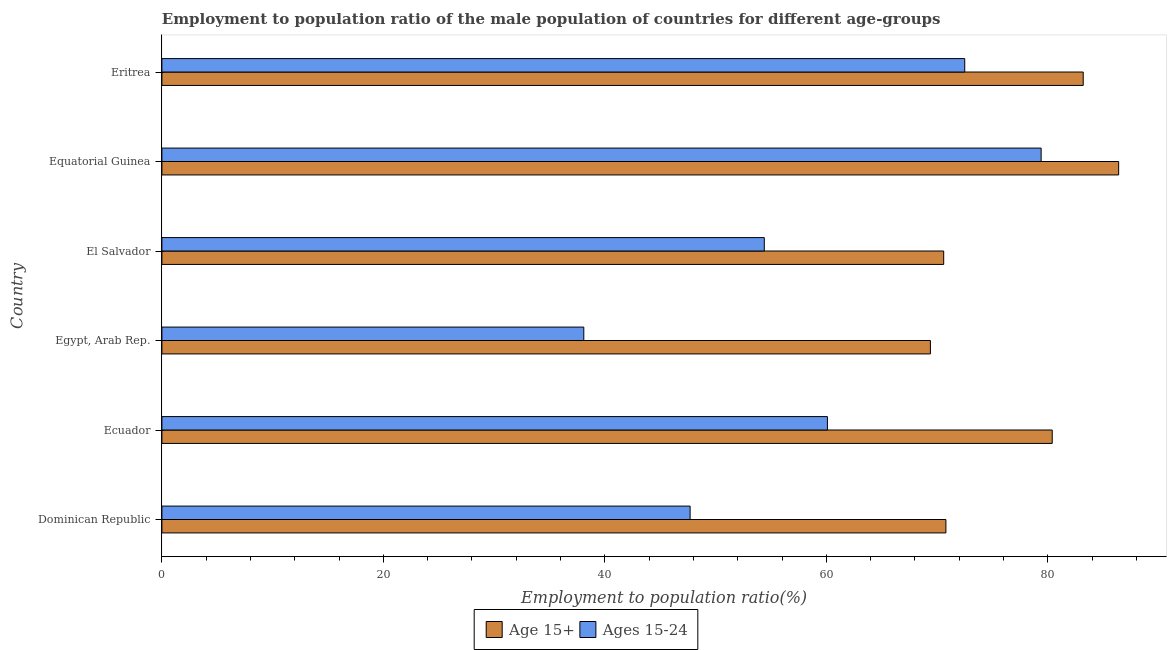What is the label of the 2nd group of bars from the top?
Your response must be concise. Equatorial Guinea. In how many cases, is the number of bars for a given country not equal to the number of legend labels?
Offer a very short reply. 0. What is the employment to population ratio(age 15-24) in Equatorial Guinea?
Keep it short and to the point. 79.4. Across all countries, what is the maximum employment to population ratio(age 15-24)?
Offer a very short reply. 79.4. Across all countries, what is the minimum employment to population ratio(age 15+)?
Your answer should be very brief. 69.4. In which country was the employment to population ratio(age 15-24) maximum?
Your answer should be very brief. Equatorial Guinea. In which country was the employment to population ratio(age 15+) minimum?
Offer a very short reply. Egypt, Arab Rep. What is the total employment to population ratio(age 15-24) in the graph?
Keep it short and to the point. 352.2. What is the difference between the employment to population ratio(age 15-24) in Egypt, Arab Rep. and that in Eritrea?
Provide a short and direct response. -34.4. What is the difference between the employment to population ratio(age 15+) in Ecuador and the employment to population ratio(age 15-24) in Eritrea?
Your response must be concise. 7.9. What is the average employment to population ratio(age 15-24) per country?
Your answer should be compact. 58.7. What is the difference between the employment to population ratio(age 15+) and employment to population ratio(age 15-24) in Eritrea?
Ensure brevity in your answer.  10.7. What is the ratio of the employment to population ratio(age 15-24) in Dominican Republic to that in Egypt, Arab Rep.?
Your answer should be compact. 1.25. Is the employment to population ratio(age 15+) in Egypt, Arab Rep. less than that in Eritrea?
Your answer should be compact. Yes. What is the difference between the highest and the second highest employment to population ratio(age 15-24)?
Your response must be concise. 6.9. What is the difference between the highest and the lowest employment to population ratio(age 15-24)?
Keep it short and to the point. 41.3. In how many countries, is the employment to population ratio(age 15+) greater than the average employment to population ratio(age 15+) taken over all countries?
Your answer should be very brief. 3. What does the 1st bar from the top in Dominican Republic represents?
Provide a short and direct response. Ages 15-24. What does the 2nd bar from the bottom in El Salvador represents?
Make the answer very short. Ages 15-24. How many bars are there?
Offer a very short reply. 12. Are all the bars in the graph horizontal?
Make the answer very short. Yes. Does the graph contain grids?
Provide a short and direct response. No. Where does the legend appear in the graph?
Provide a short and direct response. Bottom center. How many legend labels are there?
Your answer should be compact. 2. How are the legend labels stacked?
Offer a very short reply. Horizontal. What is the title of the graph?
Your answer should be compact. Employment to population ratio of the male population of countries for different age-groups. What is the Employment to population ratio(%) of Age 15+ in Dominican Republic?
Provide a short and direct response. 70.8. What is the Employment to population ratio(%) of Ages 15-24 in Dominican Republic?
Ensure brevity in your answer.  47.7. What is the Employment to population ratio(%) in Age 15+ in Ecuador?
Give a very brief answer. 80.4. What is the Employment to population ratio(%) of Ages 15-24 in Ecuador?
Keep it short and to the point. 60.1. What is the Employment to population ratio(%) of Age 15+ in Egypt, Arab Rep.?
Provide a short and direct response. 69.4. What is the Employment to population ratio(%) in Ages 15-24 in Egypt, Arab Rep.?
Offer a terse response. 38.1. What is the Employment to population ratio(%) in Age 15+ in El Salvador?
Provide a short and direct response. 70.6. What is the Employment to population ratio(%) of Ages 15-24 in El Salvador?
Keep it short and to the point. 54.4. What is the Employment to population ratio(%) in Age 15+ in Equatorial Guinea?
Your answer should be very brief. 86.4. What is the Employment to population ratio(%) in Ages 15-24 in Equatorial Guinea?
Offer a very short reply. 79.4. What is the Employment to population ratio(%) in Age 15+ in Eritrea?
Provide a succinct answer. 83.2. What is the Employment to population ratio(%) in Ages 15-24 in Eritrea?
Ensure brevity in your answer.  72.5. Across all countries, what is the maximum Employment to population ratio(%) of Age 15+?
Make the answer very short. 86.4. Across all countries, what is the maximum Employment to population ratio(%) in Ages 15-24?
Offer a terse response. 79.4. Across all countries, what is the minimum Employment to population ratio(%) of Age 15+?
Offer a very short reply. 69.4. Across all countries, what is the minimum Employment to population ratio(%) of Ages 15-24?
Your answer should be compact. 38.1. What is the total Employment to population ratio(%) in Age 15+ in the graph?
Your answer should be very brief. 460.8. What is the total Employment to population ratio(%) in Ages 15-24 in the graph?
Keep it short and to the point. 352.2. What is the difference between the Employment to population ratio(%) of Age 15+ in Dominican Republic and that in Ecuador?
Provide a short and direct response. -9.6. What is the difference between the Employment to population ratio(%) of Ages 15-24 in Dominican Republic and that in Ecuador?
Keep it short and to the point. -12.4. What is the difference between the Employment to population ratio(%) in Ages 15-24 in Dominican Republic and that in El Salvador?
Ensure brevity in your answer.  -6.7. What is the difference between the Employment to population ratio(%) of Age 15+ in Dominican Republic and that in Equatorial Guinea?
Offer a terse response. -15.6. What is the difference between the Employment to population ratio(%) of Ages 15-24 in Dominican Republic and that in Equatorial Guinea?
Provide a short and direct response. -31.7. What is the difference between the Employment to population ratio(%) of Ages 15-24 in Dominican Republic and that in Eritrea?
Offer a terse response. -24.8. What is the difference between the Employment to population ratio(%) in Age 15+ in Ecuador and that in Egypt, Arab Rep.?
Provide a succinct answer. 11. What is the difference between the Employment to population ratio(%) of Age 15+ in Ecuador and that in El Salvador?
Your answer should be compact. 9.8. What is the difference between the Employment to population ratio(%) in Ages 15-24 in Ecuador and that in Equatorial Guinea?
Give a very brief answer. -19.3. What is the difference between the Employment to population ratio(%) in Ages 15-24 in Egypt, Arab Rep. and that in El Salvador?
Provide a succinct answer. -16.3. What is the difference between the Employment to population ratio(%) in Ages 15-24 in Egypt, Arab Rep. and that in Equatorial Guinea?
Offer a very short reply. -41.3. What is the difference between the Employment to population ratio(%) of Age 15+ in Egypt, Arab Rep. and that in Eritrea?
Provide a succinct answer. -13.8. What is the difference between the Employment to population ratio(%) of Ages 15-24 in Egypt, Arab Rep. and that in Eritrea?
Offer a very short reply. -34.4. What is the difference between the Employment to population ratio(%) in Age 15+ in El Salvador and that in Equatorial Guinea?
Your answer should be compact. -15.8. What is the difference between the Employment to population ratio(%) in Age 15+ in El Salvador and that in Eritrea?
Provide a short and direct response. -12.6. What is the difference between the Employment to population ratio(%) in Ages 15-24 in El Salvador and that in Eritrea?
Provide a succinct answer. -18.1. What is the difference between the Employment to population ratio(%) in Ages 15-24 in Equatorial Guinea and that in Eritrea?
Your answer should be very brief. 6.9. What is the difference between the Employment to population ratio(%) of Age 15+ in Dominican Republic and the Employment to population ratio(%) of Ages 15-24 in Ecuador?
Make the answer very short. 10.7. What is the difference between the Employment to population ratio(%) in Age 15+ in Dominican Republic and the Employment to population ratio(%) in Ages 15-24 in Egypt, Arab Rep.?
Make the answer very short. 32.7. What is the difference between the Employment to population ratio(%) of Age 15+ in Dominican Republic and the Employment to population ratio(%) of Ages 15-24 in El Salvador?
Offer a very short reply. 16.4. What is the difference between the Employment to population ratio(%) of Age 15+ in Ecuador and the Employment to population ratio(%) of Ages 15-24 in Egypt, Arab Rep.?
Your answer should be compact. 42.3. What is the difference between the Employment to population ratio(%) in Age 15+ in Egypt, Arab Rep. and the Employment to population ratio(%) in Ages 15-24 in Eritrea?
Offer a very short reply. -3.1. What is the difference between the Employment to population ratio(%) in Age 15+ in Equatorial Guinea and the Employment to population ratio(%) in Ages 15-24 in Eritrea?
Keep it short and to the point. 13.9. What is the average Employment to population ratio(%) in Age 15+ per country?
Offer a terse response. 76.8. What is the average Employment to population ratio(%) of Ages 15-24 per country?
Keep it short and to the point. 58.7. What is the difference between the Employment to population ratio(%) in Age 15+ and Employment to population ratio(%) in Ages 15-24 in Dominican Republic?
Your answer should be very brief. 23.1. What is the difference between the Employment to population ratio(%) of Age 15+ and Employment to population ratio(%) of Ages 15-24 in Ecuador?
Your response must be concise. 20.3. What is the difference between the Employment to population ratio(%) of Age 15+ and Employment to population ratio(%) of Ages 15-24 in Egypt, Arab Rep.?
Offer a very short reply. 31.3. What is the difference between the Employment to population ratio(%) of Age 15+ and Employment to population ratio(%) of Ages 15-24 in El Salvador?
Your response must be concise. 16.2. What is the difference between the Employment to population ratio(%) of Age 15+ and Employment to population ratio(%) of Ages 15-24 in Equatorial Guinea?
Your answer should be very brief. 7. What is the ratio of the Employment to population ratio(%) in Age 15+ in Dominican Republic to that in Ecuador?
Your response must be concise. 0.88. What is the ratio of the Employment to population ratio(%) in Ages 15-24 in Dominican Republic to that in Ecuador?
Your answer should be very brief. 0.79. What is the ratio of the Employment to population ratio(%) in Age 15+ in Dominican Republic to that in Egypt, Arab Rep.?
Your response must be concise. 1.02. What is the ratio of the Employment to population ratio(%) in Ages 15-24 in Dominican Republic to that in Egypt, Arab Rep.?
Provide a short and direct response. 1.25. What is the ratio of the Employment to population ratio(%) of Ages 15-24 in Dominican Republic to that in El Salvador?
Offer a terse response. 0.88. What is the ratio of the Employment to population ratio(%) in Age 15+ in Dominican Republic to that in Equatorial Guinea?
Give a very brief answer. 0.82. What is the ratio of the Employment to population ratio(%) in Ages 15-24 in Dominican Republic to that in Equatorial Guinea?
Offer a very short reply. 0.6. What is the ratio of the Employment to population ratio(%) of Age 15+ in Dominican Republic to that in Eritrea?
Ensure brevity in your answer.  0.85. What is the ratio of the Employment to population ratio(%) in Ages 15-24 in Dominican Republic to that in Eritrea?
Keep it short and to the point. 0.66. What is the ratio of the Employment to population ratio(%) in Age 15+ in Ecuador to that in Egypt, Arab Rep.?
Give a very brief answer. 1.16. What is the ratio of the Employment to population ratio(%) of Ages 15-24 in Ecuador to that in Egypt, Arab Rep.?
Keep it short and to the point. 1.58. What is the ratio of the Employment to population ratio(%) in Age 15+ in Ecuador to that in El Salvador?
Provide a short and direct response. 1.14. What is the ratio of the Employment to population ratio(%) of Ages 15-24 in Ecuador to that in El Salvador?
Your answer should be compact. 1.1. What is the ratio of the Employment to population ratio(%) in Age 15+ in Ecuador to that in Equatorial Guinea?
Provide a succinct answer. 0.93. What is the ratio of the Employment to population ratio(%) of Ages 15-24 in Ecuador to that in Equatorial Guinea?
Ensure brevity in your answer.  0.76. What is the ratio of the Employment to population ratio(%) of Age 15+ in Ecuador to that in Eritrea?
Provide a short and direct response. 0.97. What is the ratio of the Employment to population ratio(%) in Ages 15-24 in Ecuador to that in Eritrea?
Give a very brief answer. 0.83. What is the ratio of the Employment to population ratio(%) in Ages 15-24 in Egypt, Arab Rep. to that in El Salvador?
Keep it short and to the point. 0.7. What is the ratio of the Employment to population ratio(%) in Age 15+ in Egypt, Arab Rep. to that in Equatorial Guinea?
Give a very brief answer. 0.8. What is the ratio of the Employment to population ratio(%) of Ages 15-24 in Egypt, Arab Rep. to that in Equatorial Guinea?
Keep it short and to the point. 0.48. What is the ratio of the Employment to population ratio(%) of Age 15+ in Egypt, Arab Rep. to that in Eritrea?
Your answer should be compact. 0.83. What is the ratio of the Employment to population ratio(%) of Ages 15-24 in Egypt, Arab Rep. to that in Eritrea?
Your answer should be very brief. 0.53. What is the ratio of the Employment to population ratio(%) in Age 15+ in El Salvador to that in Equatorial Guinea?
Make the answer very short. 0.82. What is the ratio of the Employment to population ratio(%) in Ages 15-24 in El Salvador to that in Equatorial Guinea?
Your answer should be very brief. 0.69. What is the ratio of the Employment to population ratio(%) of Age 15+ in El Salvador to that in Eritrea?
Make the answer very short. 0.85. What is the ratio of the Employment to population ratio(%) in Ages 15-24 in El Salvador to that in Eritrea?
Offer a very short reply. 0.75. What is the ratio of the Employment to population ratio(%) of Age 15+ in Equatorial Guinea to that in Eritrea?
Offer a terse response. 1.04. What is the ratio of the Employment to population ratio(%) in Ages 15-24 in Equatorial Guinea to that in Eritrea?
Your answer should be very brief. 1.1. What is the difference between the highest and the lowest Employment to population ratio(%) of Age 15+?
Your response must be concise. 17. What is the difference between the highest and the lowest Employment to population ratio(%) in Ages 15-24?
Keep it short and to the point. 41.3. 